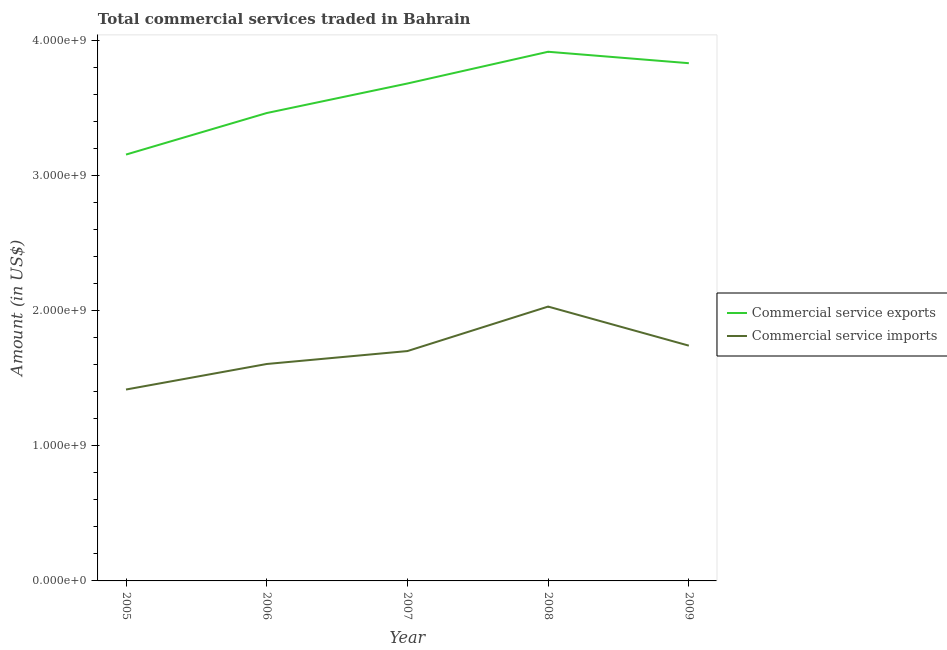How many different coloured lines are there?
Provide a succinct answer. 2. Does the line corresponding to amount of commercial service exports intersect with the line corresponding to amount of commercial service imports?
Your response must be concise. No. What is the amount of commercial service imports in 2008?
Offer a very short reply. 2.03e+09. Across all years, what is the maximum amount of commercial service exports?
Offer a terse response. 3.92e+09. Across all years, what is the minimum amount of commercial service exports?
Your answer should be compact. 3.15e+09. In which year was the amount of commercial service imports maximum?
Your answer should be very brief. 2008. What is the total amount of commercial service imports in the graph?
Your answer should be very brief. 8.49e+09. What is the difference between the amount of commercial service imports in 2006 and that in 2009?
Keep it short and to the point. -1.36e+08. What is the difference between the amount of commercial service imports in 2006 and the amount of commercial service exports in 2005?
Offer a very short reply. -1.55e+09. What is the average amount of commercial service exports per year?
Your answer should be compact. 3.61e+09. In the year 2005, what is the difference between the amount of commercial service exports and amount of commercial service imports?
Provide a short and direct response. 1.74e+09. What is the ratio of the amount of commercial service exports in 2005 to that in 2006?
Keep it short and to the point. 0.91. Is the amount of commercial service exports in 2005 less than that in 2008?
Give a very brief answer. Yes. Is the difference between the amount of commercial service exports in 2006 and 2007 greater than the difference between the amount of commercial service imports in 2006 and 2007?
Offer a terse response. No. What is the difference between the highest and the second highest amount of commercial service imports?
Make the answer very short. 2.89e+08. What is the difference between the highest and the lowest amount of commercial service exports?
Your answer should be very brief. 7.61e+08. In how many years, is the amount of commercial service imports greater than the average amount of commercial service imports taken over all years?
Offer a very short reply. 3. Is the amount of commercial service imports strictly greater than the amount of commercial service exports over the years?
Offer a terse response. No. What is the difference between two consecutive major ticks on the Y-axis?
Your response must be concise. 1.00e+09. Does the graph contain any zero values?
Your answer should be compact. No. Where does the legend appear in the graph?
Your answer should be very brief. Center right. How many legend labels are there?
Provide a succinct answer. 2. What is the title of the graph?
Keep it short and to the point. Total commercial services traded in Bahrain. What is the label or title of the X-axis?
Provide a succinct answer. Year. What is the label or title of the Y-axis?
Ensure brevity in your answer.  Amount (in US$). What is the Amount (in US$) of Commercial service exports in 2005?
Give a very brief answer. 3.15e+09. What is the Amount (in US$) of Commercial service imports in 2005?
Give a very brief answer. 1.42e+09. What is the Amount (in US$) in Commercial service exports in 2006?
Your answer should be compact. 3.46e+09. What is the Amount (in US$) in Commercial service imports in 2006?
Give a very brief answer. 1.61e+09. What is the Amount (in US$) in Commercial service exports in 2007?
Your response must be concise. 3.68e+09. What is the Amount (in US$) of Commercial service imports in 2007?
Keep it short and to the point. 1.70e+09. What is the Amount (in US$) in Commercial service exports in 2008?
Give a very brief answer. 3.92e+09. What is the Amount (in US$) of Commercial service imports in 2008?
Your answer should be very brief. 2.03e+09. What is the Amount (in US$) in Commercial service exports in 2009?
Ensure brevity in your answer.  3.83e+09. What is the Amount (in US$) of Commercial service imports in 2009?
Keep it short and to the point. 1.74e+09. Across all years, what is the maximum Amount (in US$) in Commercial service exports?
Your response must be concise. 3.92e+09. Across all years, what is the maximum Amount (in US$) in Commercial service imports?
Your response must be concise. 2.03e+09. Across all years, what is the minimum Amount (in US$) of Commercial service exports?
Keep it short and to the point. 3.15e+09. Across all years, what is the minimum Amount (in US$) in Commercial service imports?
Your answer should be compact. 1.42e+09. What is the total Amount (in US$) in Commercial service exports in the graph?
Your response must be concise. 1.80e+1. What is the total Amount (in US$) in Commercial service imports in the graph?
Provide a succinct answer. 8.49e+09. What is the difference between the Amount (in US$) in Commercial service exports in 2005 and that in 2006?
Ensure brevity in your answer.  -3.07e+08. What is the difference between the Amount (in US$) in Commercial service imports in 2005 and that in 2006?
Provide a succinct answer. -1.89e+08. What is the difference between the Amount (in US$) in Commercial service exports in 2005 and that in 2007?
Your answer should be compact. -5.26e+08. What is the difference between the Amount (in US$) in Commercial service imports in 2005 and that in 2007?
Keep it short and to the point. -2.85e+08. What is the difference between the Amount (in US$) in Commercial service exports in 2005 and that in 2008?
Your answer should be very brief. -7.61e+08. What is the difference between the Amount (in US$) of Commercial service imports in 2005 and that in 2008?
Ensure brevity in your answer.  -6.14e+08. What is the difference between the Amount (in US$) in Commercial service exports in 2005 and that in 2009?
Provide a succinct answer. -6.76e+08. What is the difference between the Amount (in US$) in Commercial service imports in 2005 and that in 2009?
Ensure brevity in your answer.  -3.25e+08. What is the difference between the Amount (in US$) in Commercial service exports in 2006 and that in 2007?
Offer a terse response. -2.19e+08. What is the difference between the Amount (in US$) in Commercial service imports in 2006 and that in 2007?
Offer a terse response. -9.57e+07. What is the difference between the Amount (in US$) in Commercial service exports in 2006 and that in 2008?
Your answer should be very brief. -4.53e+08. What is the difference between the Amount (in US$) of Commercial service imports in 2006 and that in 2008?
Your answer should be very brief. -4.25e+08. What is the difference between the Amount (in US$) in Commercial service exports in 2006 and that in 2009?
Keep it short and to the point. -3.69e+08. What is the difference between the Amount (in US$) of Commercial service imports in 2006 and that in 2009?
Give a very brief answer. -1.36e+08. What is the difference between the Amount (in US$) of Commercial service exports in 2007 and that in 2008?
Give a very brief answer. -2.35e+08. What is the difference between the Amount (in US$) of Commercial service imports in 2007 and that in 2008?
Ensure brevity in your answer.  -3.29e+08. What is the difference between the Amount (in US$) of Commercial service exports in 2007 and that in 2009?
Your answer should be very brief. -1.50e+08. What is the difference between the Amount (in US$) in Commercial service imports in 2007 and that in 2009?
Provide a short and direct response. -4.00e+07. What is the difference between the Amount (in US$) of Commercial service exports in 2008 and that in 2009?
Make the answer very short. 8.46e+07. What is the difference between the Amount (in US$) of Commercial service imports in 2008 and that in 2009?
Give a very brief answer. 2.89e+08. What is the difference between the Amount (in US$) of Commercial service exports in 2005 and the Amount (in US$) of Commercial service imports in 2006?
Make the answer very short. 1.55e+09. What is the difference between the Amount (in US$) of Commercial service exports in 2005 and the Amount (in US$) of Commercial service imports in 2007?
Provide a succinct answer. 1.45e+09. What is the difference between the Amount (in US$) of Commercial service exports in 2005 and the Amount (in US$) of Commercial service imports in 2008?
Your answer should be very brief. 1.12e+09. What is the difference between the Amount (in US$) of Commercial service exports in 2005 and the Amount (in US$) of Commercial service imports in 2009?
Offer a terse response. 1.41e+09. What is the difference between the Amount (in US$) in Commercial service exports in 2006 and the Amount (in US$) in Commercial service imports in 2007?
Provide a short and direct response. 1.76e+09. What is the difference between the Amount (in US$) of Commercial service exports in 2006 and the Amount (in US$) of Commercial service imports in 2008?
Provide a succinct answer. 1.43e+09. What is the difference between the Amount (in US$) in Commercial service exports in 2006 and the Amount (in US$) in Commercial service imports in 2009?
Provide a short and direct response. 1.72e+09. What is the difference between the Amount (in US$) of Commercial service exports in 2007 and the Amount (in US$) of Commercial service imports in 2008?
Your response must be concise. 1.65e+09. What is the difference between the Amount (in US$) in Commercial service exports in 2007 and the Amount (in US$) in Commercial service imports in 2009?
Ensure brevity in your answer.  1.94e+09. What is the difference between the Amount (in US$) of Commercial service exports in 2008 and the Amount (in US$) of Commercial service imports in 2009?
Your response must be concise. 2.17e+09. What is the average Amount (in US$) of Commercial service exports per year?
Give a very brief answer. 3.61e+09. What is the average Amount (in US$) of Commercial service imports per year?
Your response must be concise. 1.70e+09. In the year 2005, what is the difference between the Amount (in US$) of Commercial service exports and Amount (in US$) of Commercial service imports?
Offer a very short reply. 1.74e+09. In the year 2006, what is the difference between the Amount (in US$) in Commercial service exports and Amount (in US$) in Commercial service imports?
Offer a terse response. 1.86e+09. In the year 2007, what is the difference between the Amount (in US$) of Commercial service exports and Amount (in US$) of Commercial service imports?
Your response must be concise. 1.98e+09. In the year 2008, what is the difference between the Amount (in US$) in Commercial service exports and Amount (in US$) in Commercial service imports?
Your answer should be compact. 1.89e+09. In the year 2009, what is the difference between the Amount (in US$) in Commercial service exports and Amount (in US$) in Commercial service imports?
Your response must be concise. 2.09e+09. What is the ratio of the Amount (in US$) of Commercial service exports in 2005 to that in 2006?
Your response must be concise. 0.91. What is the ratio of the Amount (in US$) of Commercial service imports in 2005 to that in 2006?
Offer a very short reply. 0.88. What is the ratio of the Amount (in US$) in Commercial service imports in 2005 to that in 2007?
Give a very brief answer. 0.83. What is the ratio of the Amount (in US$) in Commercial service exports in 2005 to that in 2008?
Your answer should be compact. 0.81. What is the ratio of the Amount (in US$) in Commercial service imports in 2005 to that in 2008?
Keep it short and to the point. 0.7. What is the ratio of the Amount (in US$) in Commercial service exports in 2005 to that in 2009?
Keep it short and to the point. 0.82. What is the ratio of the Amount (in US$) in Commercial service imports in 2005 to that in 2009?
Provide a short and direct response. 0.81. What is the ratio of the Amount (in US$) of Commercial service exports in 2006 to that in 2007?
Your answer should be compact. 0.94. What is the ratio of the Amount (in US$) of Commercial service imports in 2006 to that in 2007?
Ensure brevity in your answer.  0.94. What is the ratio of the Amount (in US$) in Commercial service exports in 2006 to that in 2008?
Offer a terse response. 0.88. What is the ratio of the Amount (in US$) of Commercial service imports in 2006 to that in 2008?
Keep it short and to the point. 0.79. What is the ratio of the Amount (in US$) in Commercial service exports in 2006 to that in 2009?
Your answer should be very brief. 0.9. What is the ratio of the Amount (in US$) in Commercial service imports in 2006 to that in 2009?
Offer a very short reply. 0.92. What is the ratio of the Amount (in US$) in Commercial service imports in 2007 to that in 2008?
Provide a succinct answer. 0.84. What is the ratio of the Amount (in US$) in Commercial service exports in 2007 to that in 2009?
Keep it short and to the point. 0.96. What is the ratio of the Amount (in US$) of Commercial service exports in 2008 to that in 2009?
Your answer should be very brief. 1.02. What is the ratio of the Amount (in US$) of Commercial service imports in 2008 to that in 2009?
Your answer should be compact. 1.17. What is the difference between the highest and the second highest Amount (in US$) in Commercial service exports?
Give a very brief answer. 8.46e+07. What is the difference between the highest and the second highest Amount (in US$) in Commercial service imports?
Make the answer very short. 2.89e+08. What is the difference between the highest and the lowest Amount (in US$) in Commercial service exports?
Offer a very short reply. 7.61e+08. What is the difference between the highest and the lowest Amount (in US$) of Commercial service imports?
Ensure brevity in your answer.  6.14e+08. 